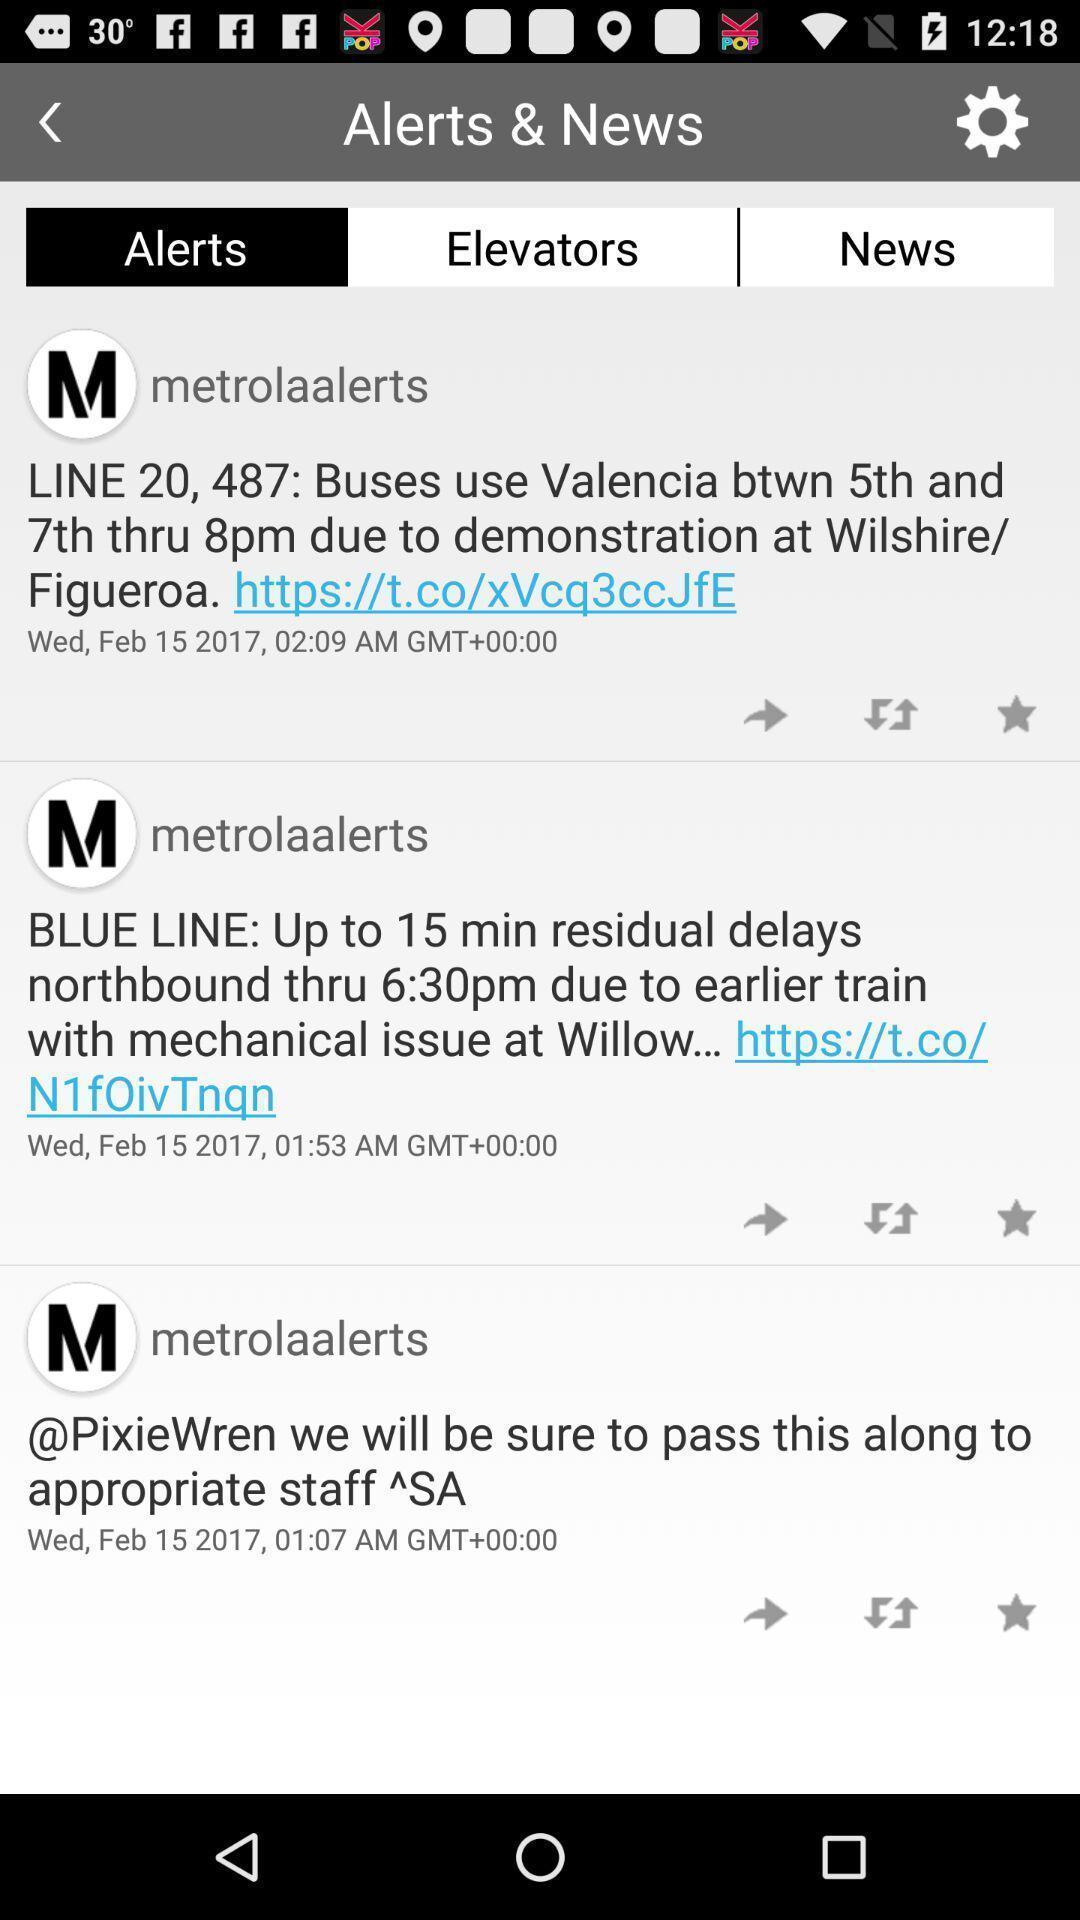Please provide a description for this image. Screen displaying a list of remainder messages. 